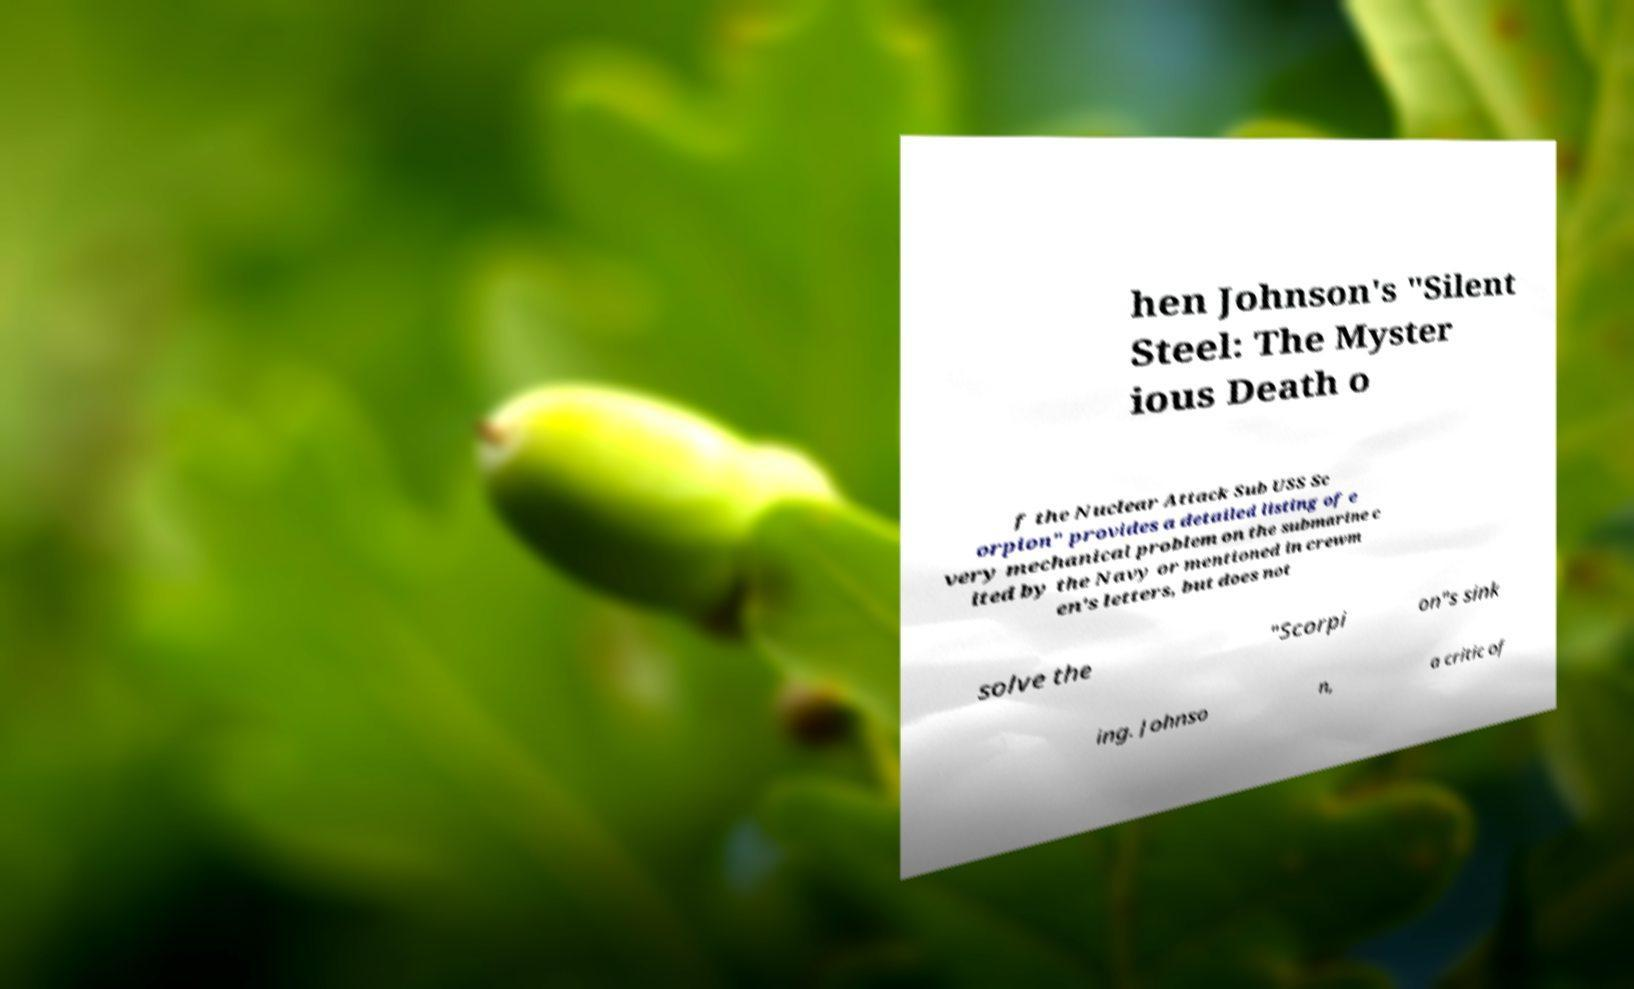Please read and relay the text visible in this image. What does it say? hen Johnson's "Silent Steel: The Myster ious Death o f the Nuclear Attack Sub USS Sc orpion" provides a detailed listing of e very mechanical problem on the submarine c ited by the Navy or mentioned in crewm en's letters, but does not solve the "Scorpi on"s sink ing. Johnso n, a critic of 